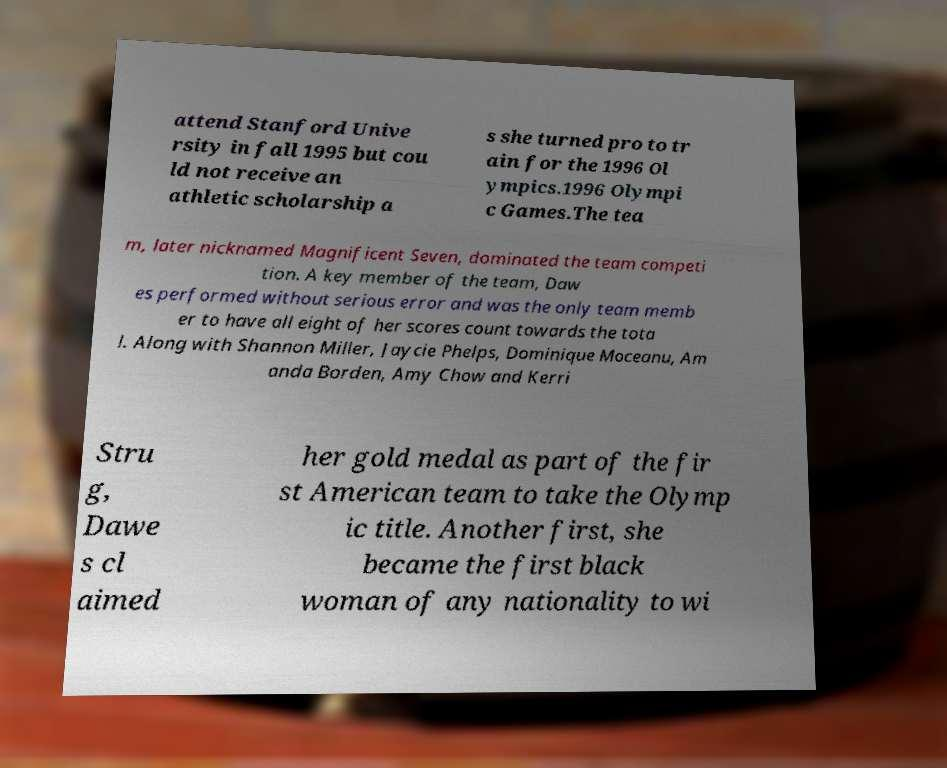I need the written content from this picture converted into text. Can you do that? attend Stanford Unive rsity in fall 1995 but cou ld not receive an athletic scholarship a s she turned pro to tr ain for the 1996 Ol ympics.1996 Olympi c Games.The tea m, later nicknamed Magnificent Seven, dominated the team competi tion. A key member of the team, Daw es performed without serious error and was the only team memb er to have all eight of her scores count towards the tota l. Along with Shannon Miller, Jaycie Phelps, Dominique Moceanu, Am anda Borden, Amy Chow and Kerri Stru g, Dawe s cl aimed her gold medal as part of the fir st American team to take the Olymp ic title. Another first, she became the first black woman of any nationality to wi 